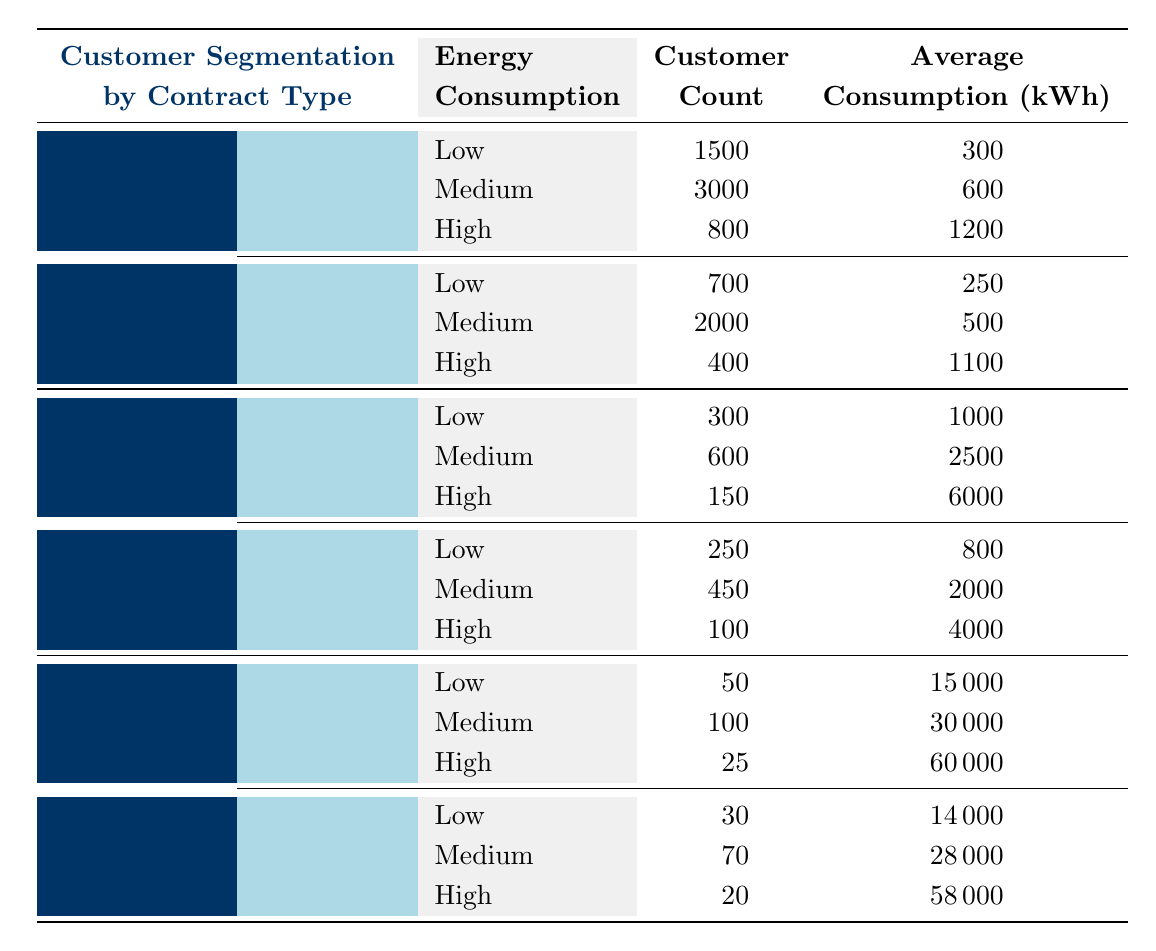What is the customer count for Residential customers with Standard contracts and High energy consumption? The table shows that for Residential customers under Standard contracts with High energy consumption, the Customer Count is 800.
Answer: 800 What is the average energy consumption in kWh for Commercial customers on Variable contracts with Medium energy consumption? The table indicates that for Commercial customers on Variable contracts and Medium energy consumption, the Average Consumption is 2000 kWh.
Answer: 2000 kWh How many Low consumption Commercial customers are there in total? To find the total Low consumption Commercial customers, add the customer counts from Fixed and Variable contracts: 300 (Fixed) + 250 (Variable) = 550.
Answer: 550 Is the average energy consumption for Industrial customers with Short-Term contracts and High consumption greater than 50000 kWh? The table states that for Industrial customers with Short-Term contracts and High energy consumption, the Average Consumption is 58000 kWh, which is greater than 50000 kWh.
Answer: Yes What is the total customer count for Residential customers with Time-of-Use contracts? To calculate this, sum the customer counts for Low, Medium, and High energy consumption: 700 + 2000 + 400 = 3100.
Answer: 3100 Which customer segment has the highest High energy consumption in kWh and what is the value? Examining the High energy consumption averages, Industrial customers with Long-Term contracts have the highest at 60000 kWh.
Answer: 60000 kWh How many total customers are there in the Residential segment compared to the Commercial segment? For Residential, total customers: 1500 + 3000 + 800 + 700 + 2000 + 400 = 6400. For Commercial: 300 + 600 + 150 + 250 + 450 + 100 = 2250. Therefore, Residential has more customers totaling 6400.
Answer: Yes What is the average customer count for each consumption level across all segments? The average customer count for Low consumption is (1500 + 700 + 300 + 250 + 50 + 30) / 6 = 375. For Medium consumption, it is (3000 + 2000 + 600 + 450 + 100 + 70) / 6 = 670. For High consumption, it is (800 + 400 + 150 + 100 + 25 + 20) / 6 = 165.
Answer: Low: 375, Medium: 670, High: 165 